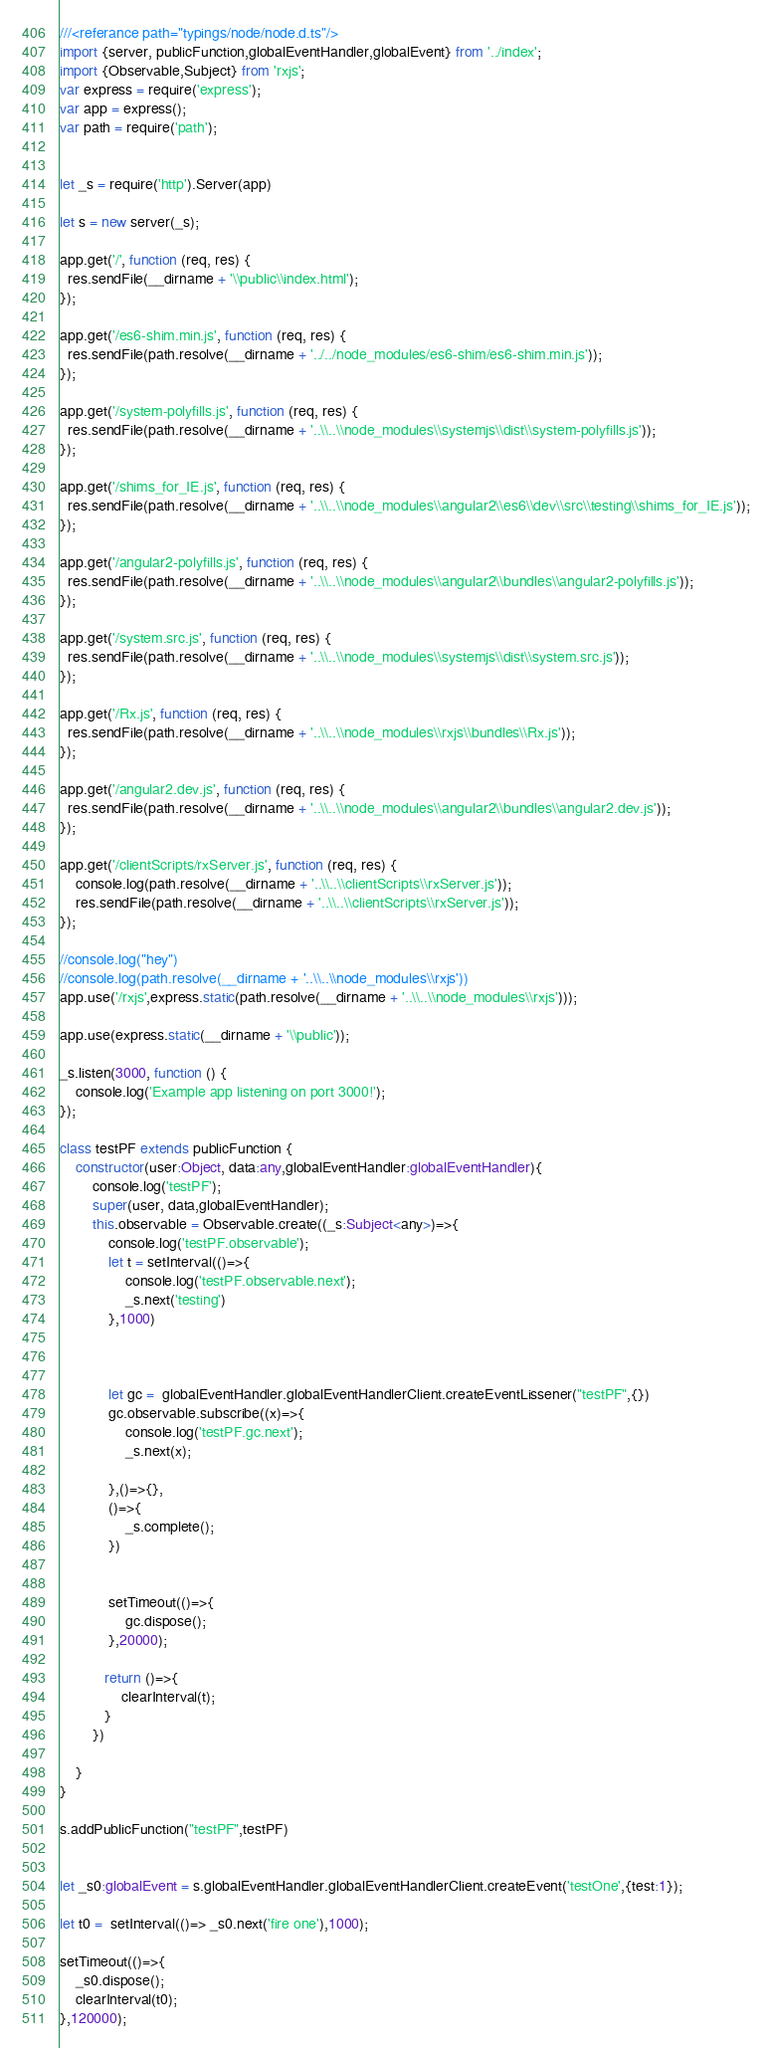<code> <loc_0><loc_0><loc_500><loc_500><_TypeScript_>///<referance path="typings/node/node.d.ts"/>
import {server, publicFunction,globalEventHandler,globalEvent} from '../index';
import {Observable,Subject} from 'rxjs';
var express = require('express');
var app = express();
var path = require('path');


let _s = require('http').Server(app)

let s = new server(_s);

app.get('/', function (req, res) {
  res.sendFile(__dirname + '\\public\\index.html');
});

app.get('/es6-shim.min.js', function (req, res) {
  res.sendFile(path.resolve(__dirname + '../../node_modules/es6-shim/es6-shim.min.js'));
});

app.get('/system-polyfills.js', function (req, res) {
  res.sendFile(path.resolve(__dirname + '..\\..\\node_modules\\systemjs\\dist\\system-polyfills.js'));
});

app.get('/shims_for_IE.js', function (req, res) {
  res.sendFile(path.resolve(__dirname + '..\\..\\node_modules\\angular2\\es6\\dev\\src\\testing\\shims_for_IE.js'));
});

app.get('/angular2-polyfills.js', function (req, res) {
  res.sendFile(path.resolve(__dirname + '..\\..\\node_modules\\angular2\\bundles\\angular2-polyfills.js'));
});

app.get('/system.src.js', function (req, res) {
  res.sendFile(path.resolve(__dirname + '..\\..\\node_modules\\systemjs\\dist\\system.src.js'));
});

app.get('/Rx.js', function (req, res) {
  res.sendFile(path.resolve(__dirname + '..\\..\\node_modules\\rxjs\\bundles\\Rx.js'));
});

app.get('/angular2.dev.js', function (req, res) {
  res.sendFile(path.resolve(__dirname + '..\\..\\node_modules\\angular2\\bundles\\angular2.dev.js'));
});

app.get('/clientScripts/rxServer.js', function (req, res) {
    console.log(path.resolve(__dirname + '..\\..\\clientScripts\\rxServer.js'));
    res.sendFile(path.resolve(__dirname + '..\\..\\clientScripts\\rxServer.js'));
});

//console.log("hey")
//console.log(path.resolve(__dirname + '..\\..\\node_modules\\rxjs'))
app.use('/rxjs',express.static(path.resolve(__dirname + '..\\..\\node_modules\\rxjs')));

app.use(express.static(__dirname + '\\public'));

_s.listen(3000, function () {
    console.log('Example app listening on port 3000!');
});

class testPF extends publicFunction {
    constructor(user:Object, data:any,globalEventHandler:globalEventHandler){
        console.log('testPF');
        super(user, data,globalEventHandler);
        this.observable = Observable.create((_s:Subject<any>)=>{
            console.log('testPF.observable');
            let t = setInterval(()=>{
                console.log('testPF.observable.next');
                _s.next('testing')
            },1000)
            

            
            let gc =  globalEventHandler.globalEventHandlerClient.createEventLissener("testPF",{})
            gc.observable.subscribe((x)=>{
                console.log('testPF.gc.next');
                _s.next(x);
                
            },()=>{},
            ()=>{
                _s.complete();
            })
            
            
            setTimeout(()=>{
                gc.dispose();
            },20000);
            
           return ()=>{
               clearInterval(t);
           }
        })

    }
}

s.addPublicFunction("testPF",testPF)


let _s0:globalEvent = s.globalEventHandler.globalEventHandlerClient.createEvent('testOne',{test:1});

let t0 =  setInterval(()=> _s0.next('fire one'),1000);

setTimeout(()=>{
    _s0.dispose();
    clearInterval(t0);
},120000);
</code> 